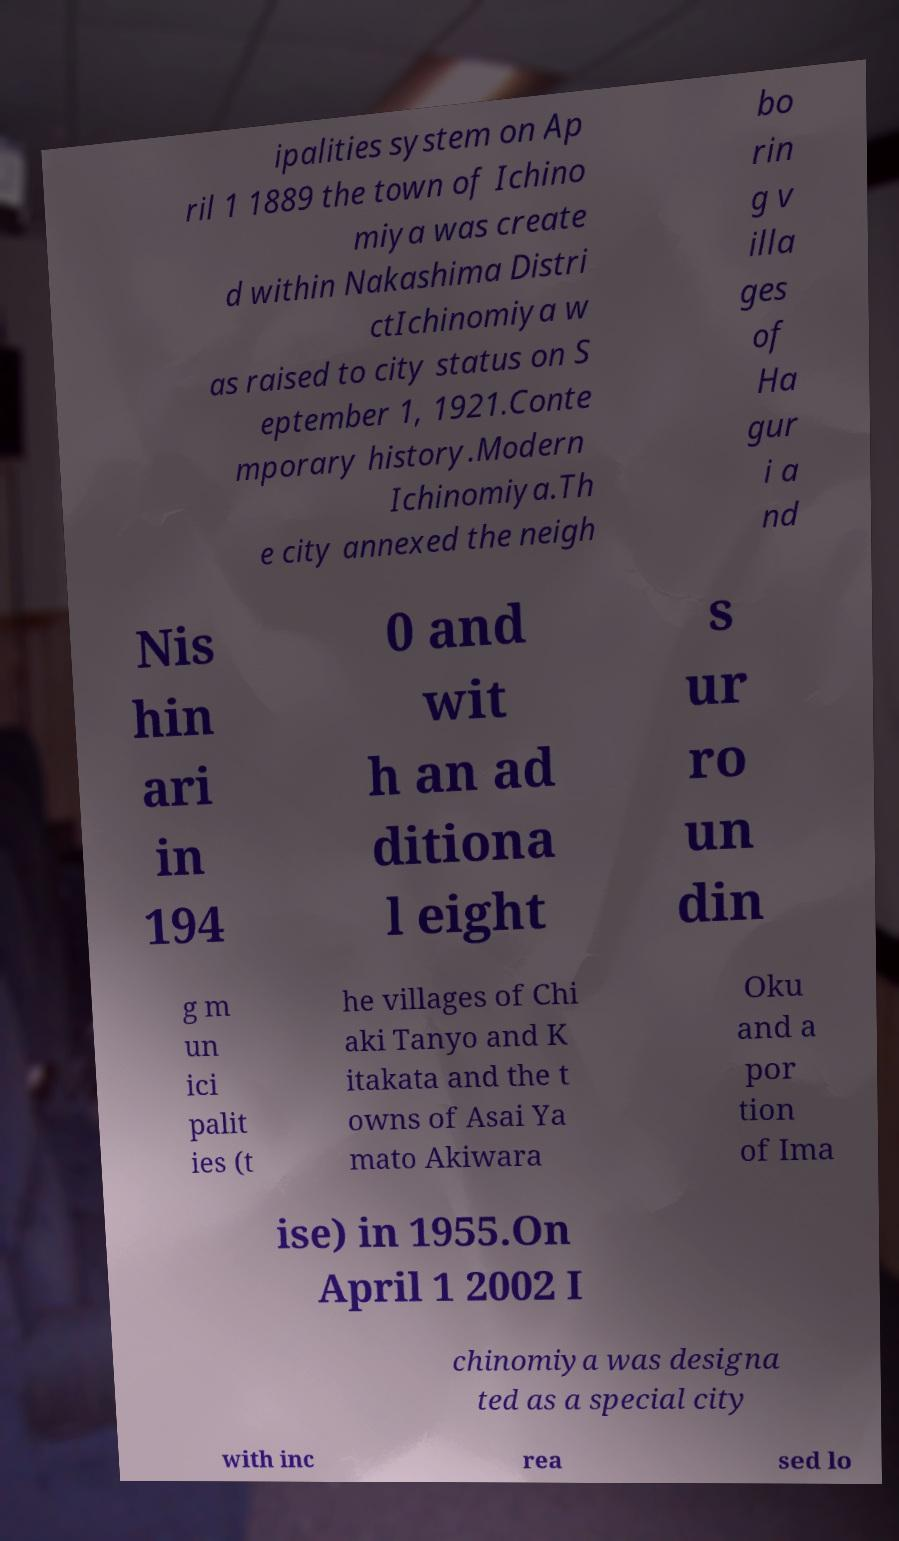What messages or text are displayed in this image? I need them in a readable, typed format. ipalities system on Ap ril 1 1889 the town of Ichino miya was create d within Nakashima Distri ctIchinomiya w as raised to city status on S eptember 1, 1921.Conte mporary history.Modern Ichinomiya.Th e city annexed the neigh bo rin g v illa ges of Ha gur i a nd Nis hin ari in 194 0 and wit h an ad ditiona l eight s ur ro un din g m un ici palit ies (t he villages of Chi aki Tanyo and K itakata and the t owns of Asai Ya mato Akiwara Oku and a por tion of Ima ise) in 1955.On April 1 2002 I chinomiya was designa ted as a special city with inc rea sed lo 